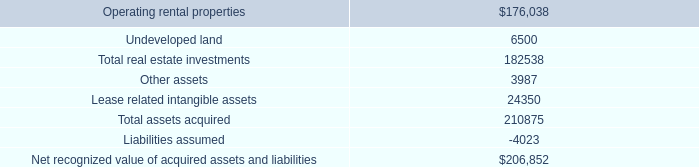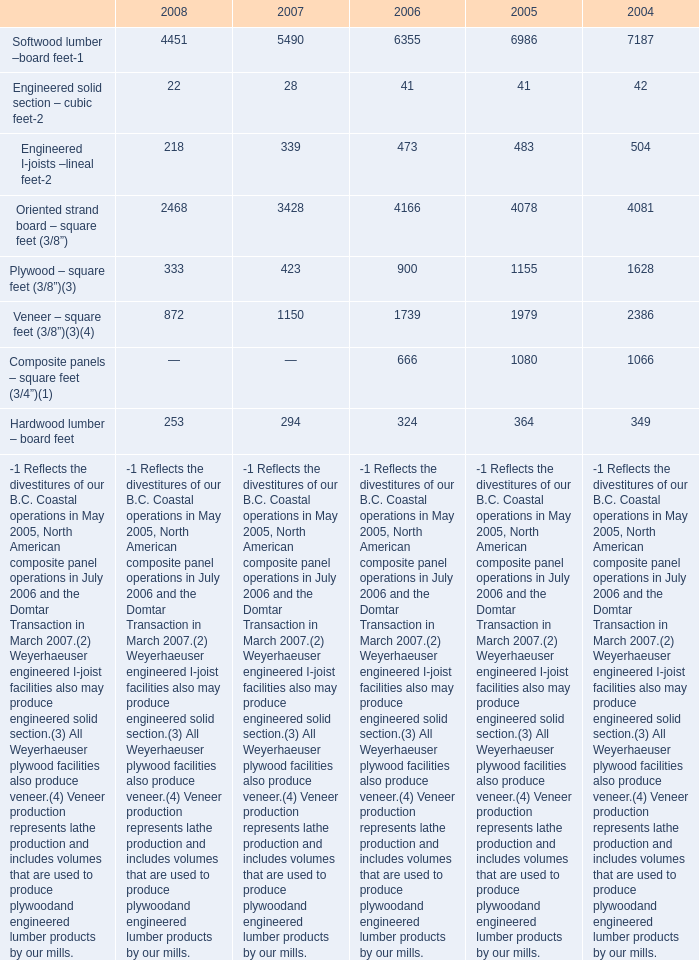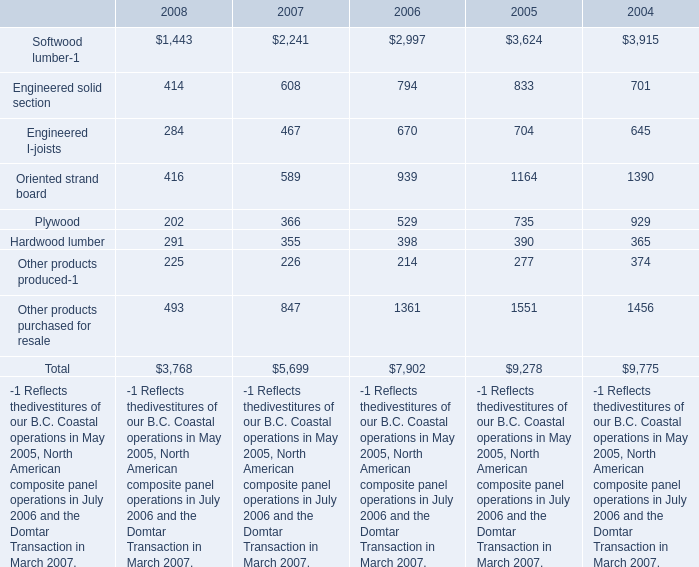What's the total amount of the Engineered solid section – cubic fee and Engineered I-joists –lineal feet in the years where Softwood lumber –board feet- is greater than 7000? 
Computations: (42 + 504)
Answer: 546.0. 